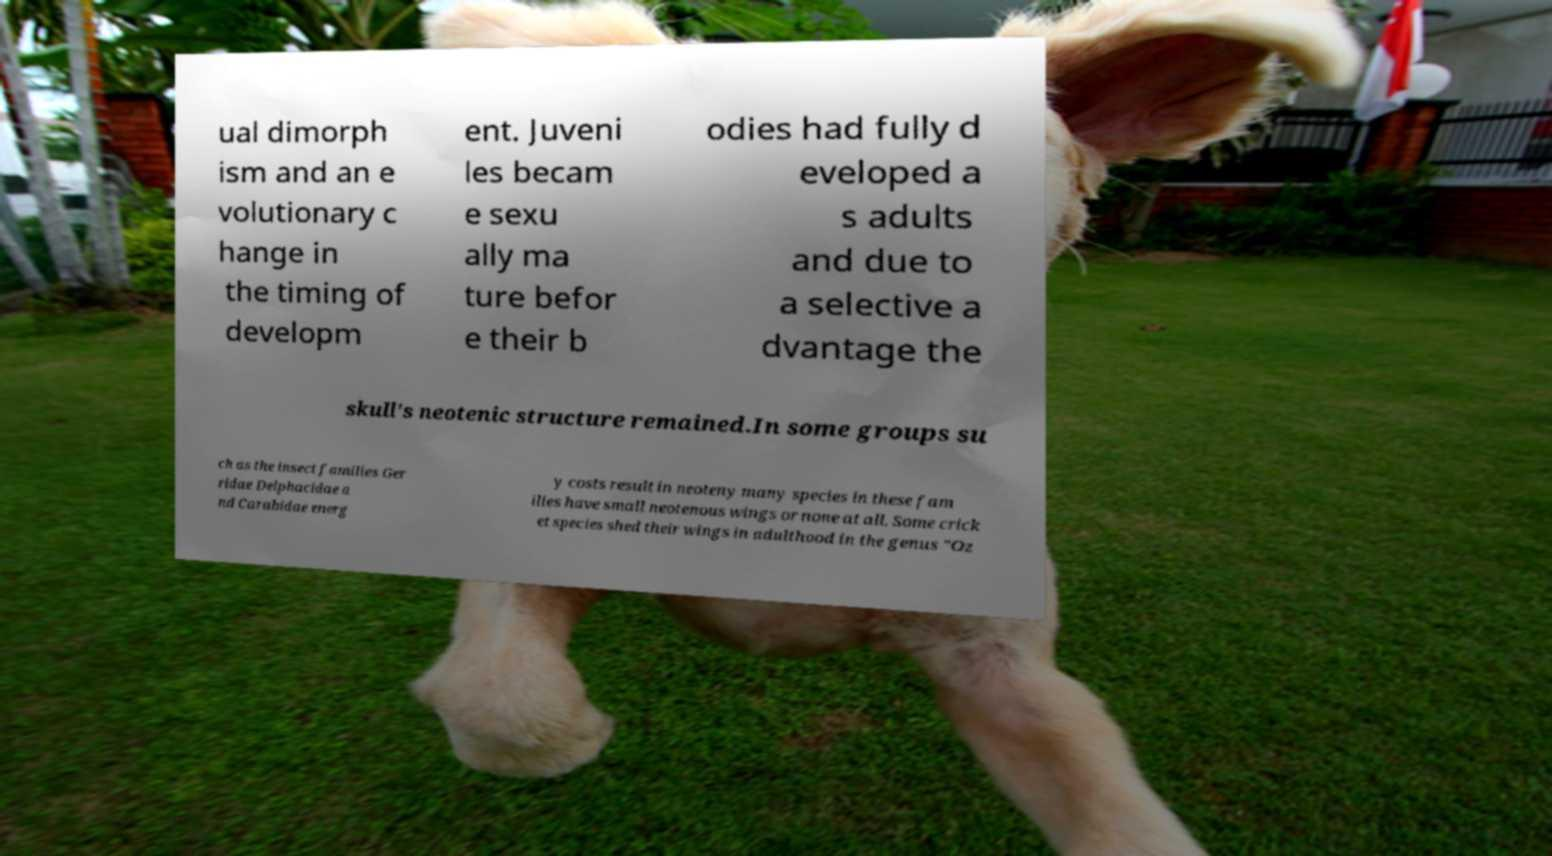Can you accurately transcribe the text from the provided image for me? ual dimorph ism and an e volutionary c hange in the timing of developm ent. Juveni les becam e sexu ally ma ture befor e their b odies had fully d eveloped a s adults and due to a selective a dvantage the skull's neotenic structure remained.In some groups su ch as the insect families Ger ridae Delphacidae a nd Carabidae energ y costs result in neoteny many species in these fam ilies have small neotenous wings or none at all. Some crick et species shed their wings in adulthood in the genus "Oz 